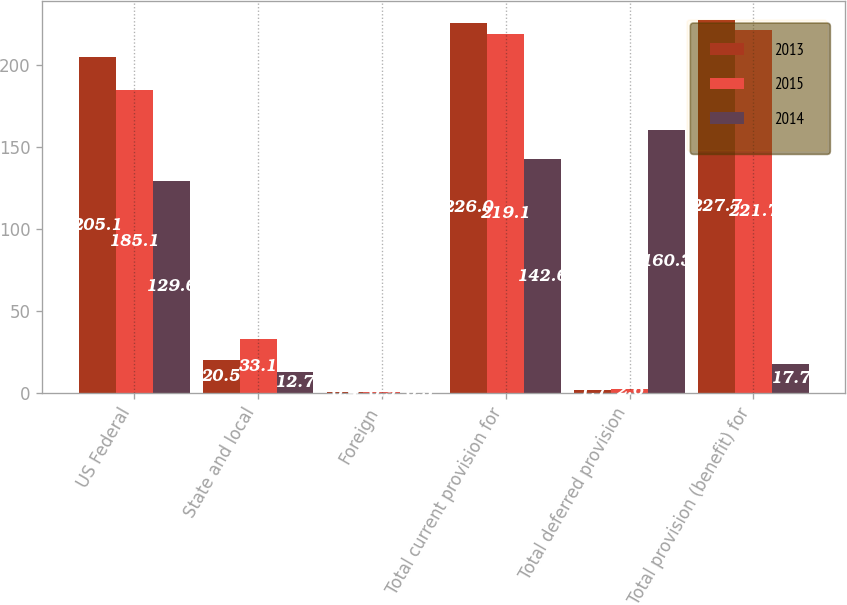Convert chart. <chart><loc_0><loc_0><loc_500><loc_500><stacked_bar_chart><ecel><fcel>US Federal<fcel>State and local<fcel>Foreign<fcel>Total current provision for<fcel>Total deferred provision<fcel>Total provision (benefit) for<nl><fcel>2013<fcel>205.1<fcel>20.5<fcel>0.4<fcel>226<fcel>1.7<fcel>227.7<nl><fcel>2015<fcel>185.1<fcel>33.1<fcel>0.9<fcel>219.1<fcel>2.6<fcel>221.7<nl><fcel>2014<fcel>129.6<fcel>12.7<fcel>0.3<fcel>142.6<fcel>160.3<fcel>17.7<nl></chart> 